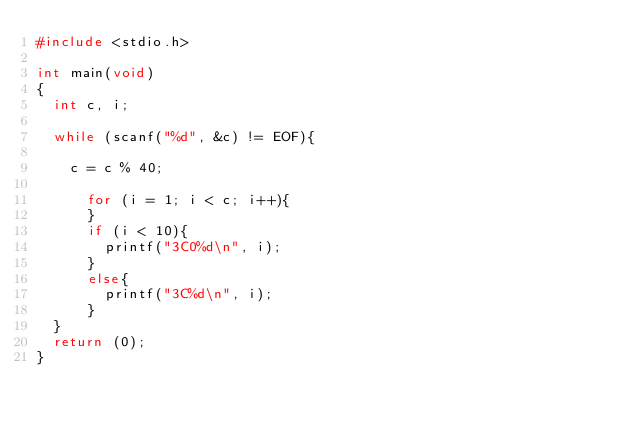Convert code to text. <code><loc_0><loc_0><loc_500><loc_500><_C_>#include <stdio.h>

int main(void)
{
	int c, i;
	
	while (scanf("%d", &c) != EOF){
		
		c = c % 40;
		
			for (i = 1; i < c; i++){
			}
			if (i < 10){
				printf("3C0%d\n", i);
			}
			else{
				printf("3C%d\n", i);
			}
	}
	return (0);
}
			
			</code> 